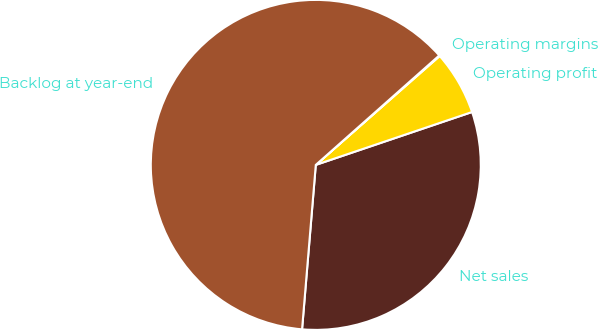Convert chart to OTSL. <chart><loc_0><loc_0><loc_500><loc_500><pie_chart><fcel>Net sales<fcel>Operating profit<fcel>Operating margins<fcel>Backlog at year-end<nl><fcel>31.52%<fcel>6.28%<fcel>0.07%<fcel>62.13%<nl></chart> 